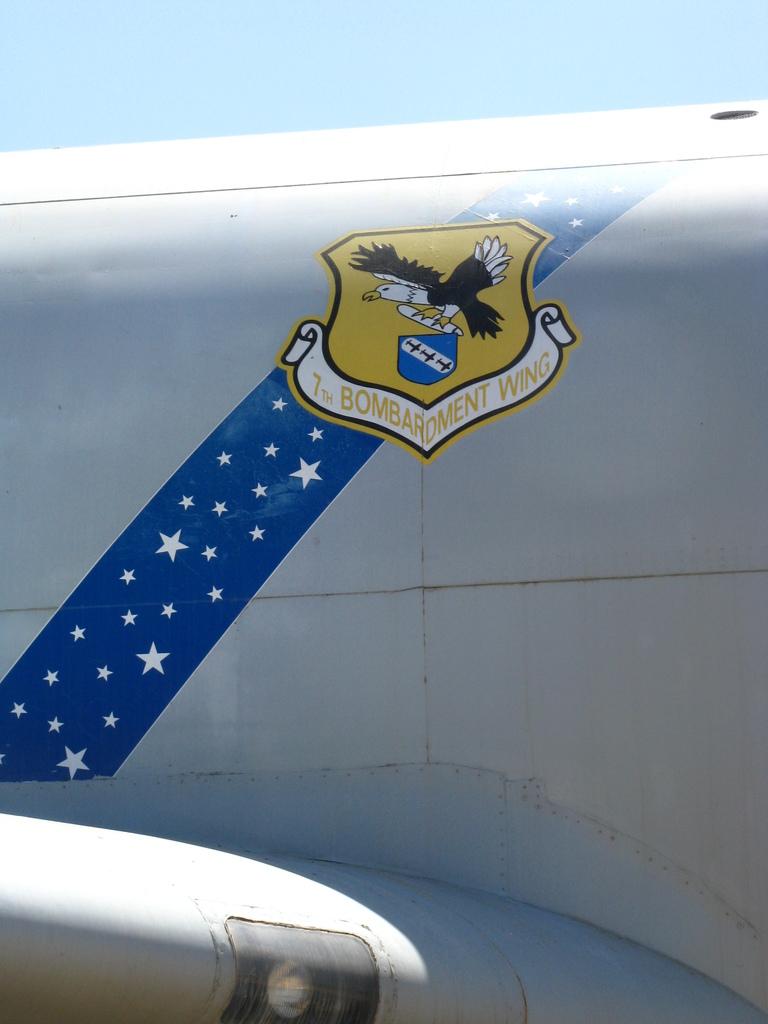Is the wing a bombardment wing?
Keep it short and to the point. Yes. What kind of wing is described?
Provide a short and direct response. Bombardment. 